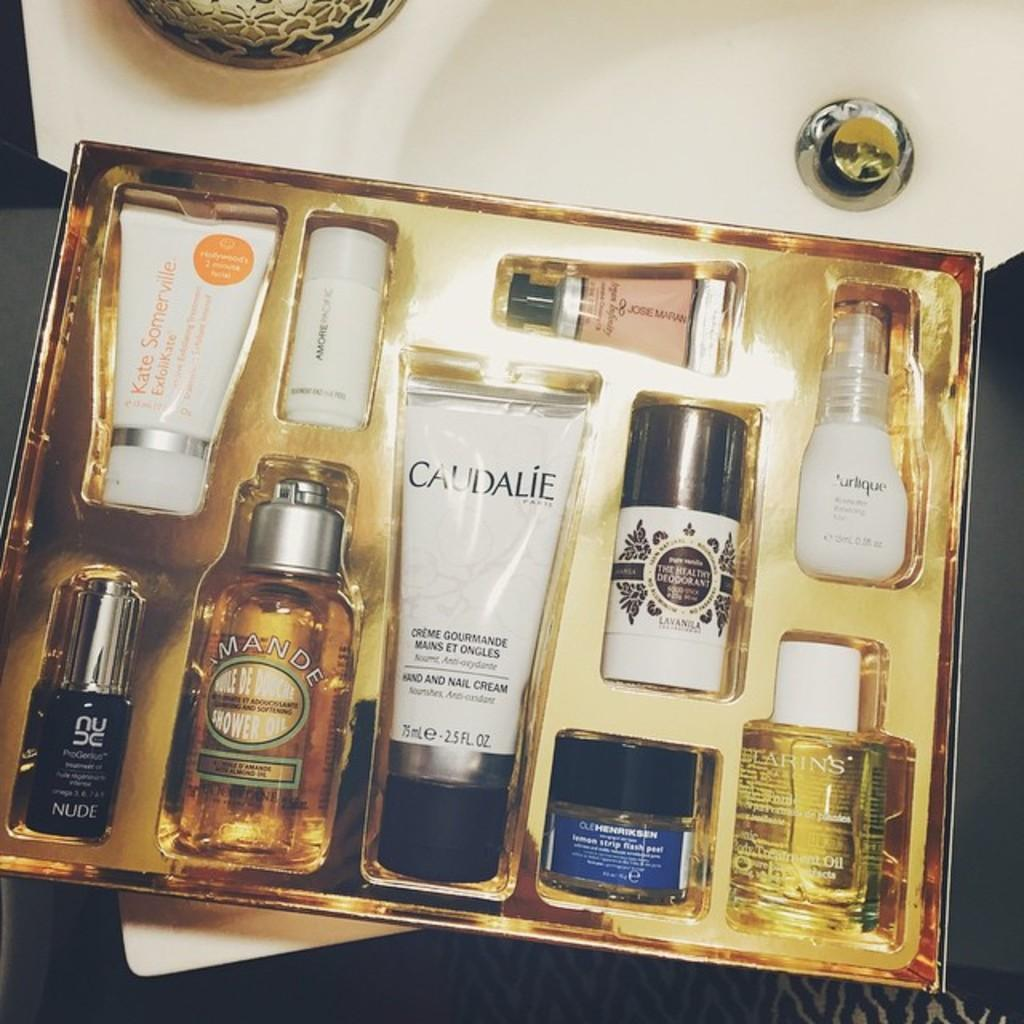<image>
Render a clear and concise summary of the photo. A skincare set that includes Kate Somerville and Caudalie products among others. 